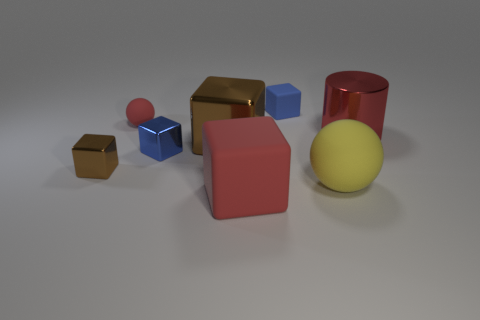What is the size of the red cube that is made of the same material as the yellow ball?
Provide a short and direct response. Large. How many brown objects are big metallic cubes or metallic cylinders?
Your response must be concise. 1. The matte thing that is the same color as the small rubber sphere is what shape?
Your response must be concise. Cube. Is there any other thing that is made of the same material as the red ball?
Make the answer very short. Yes. Is the shape of the small blue matte object that is to the right of the small sphere the same as the large thing to the right of the large yellow sphere?
Your answer should be compact. No. How many big yellow shiny cubes are there?
Keep it short and to the point. 0. There is a big red object that is the same material as the small red thing; what shape is it?
Your answer should be compact. Cube. Is there anything else that has the same color as the small matte block?
Your response must be concise. Yes. Is the color of the cylinder the same as the matte sphere that is to the left of the large yellow matte sphere?
Keep it short and to the point. Yes. Is the number of large red metal cylinders to the right of the blue rubber block less than the number of tiny cyan cylinders?
Your response must be concise. No. 